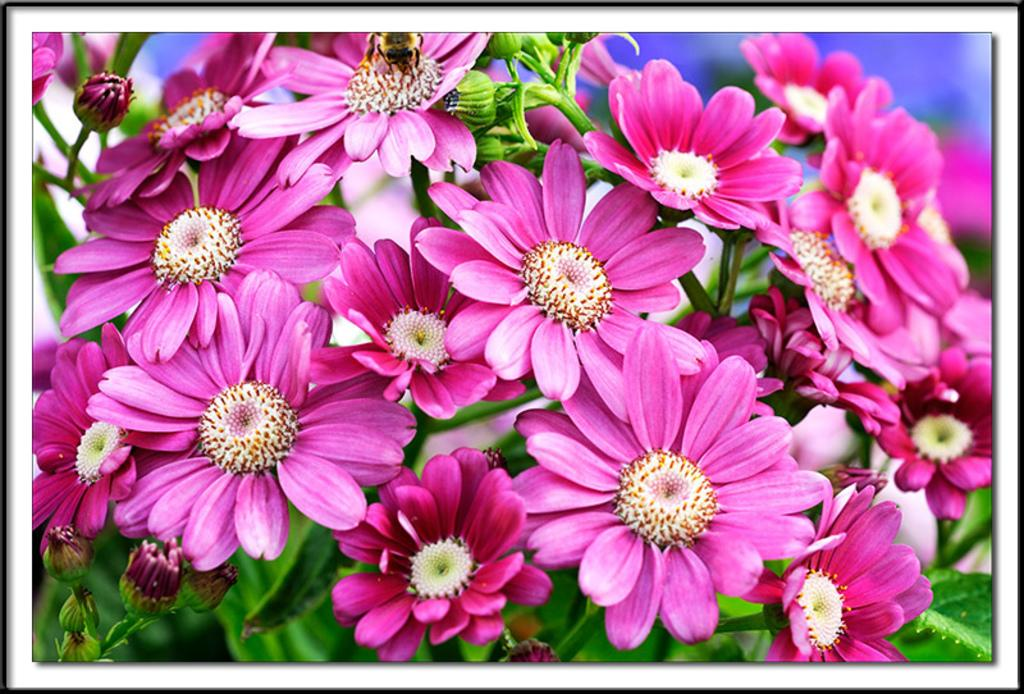What is the main subject of the image? There is a bunch of flowers in the image. Can you describe the flowers in more detail? There are some buds in the image, indicating that the flowers are not yet fully bloomed. What can be seen in the background of the image? The sky is visible in the background of the image. What type of jelly is being served to the flowers in the image? There is no jelly or serving in the image; it features a bunch of flowers with buds and a visible sky in the background. 